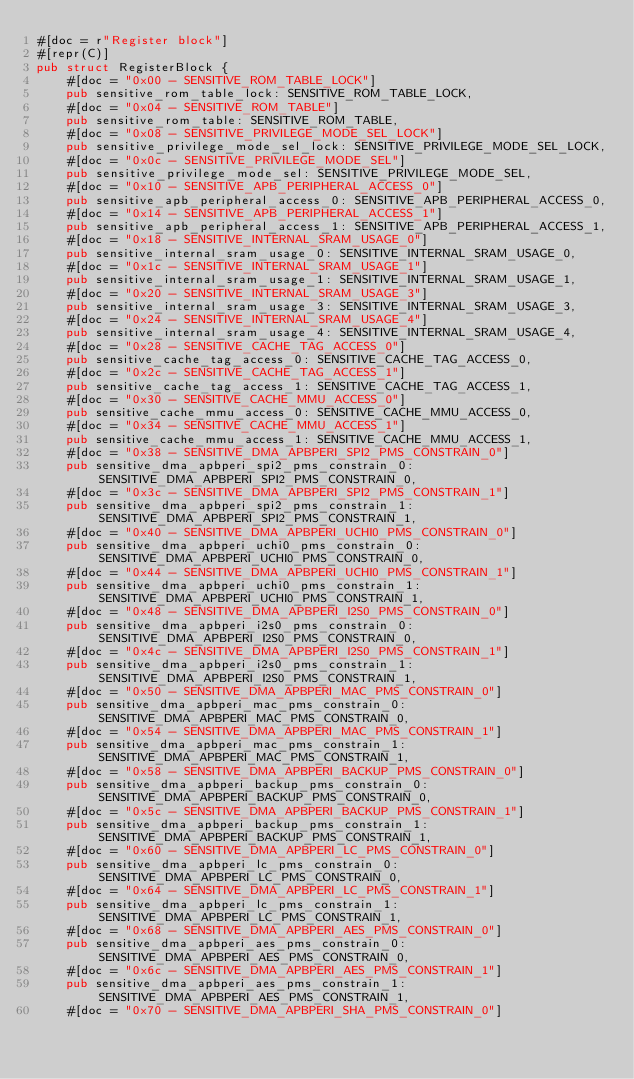<code> <loc_0><loc_0><loc_500><loc_500><_Rust_>#[doc = r"Register block"]
#[repr(C)]
pub struct RegisterBlock {
    #[doc = "0x00 - SENSITIVE_ROM_TABLE_LOCK"]
    pub sensitive_rom_table_lock: SENSITIVE_ROM_TABLE_LOCK,
    #[doc = "0x04 - SENSITIVE_ROM_TABLE"]
    pub sensitive_rom_table: SENSITIVE_ROM_TABLE,
    #[doc = "0x08 - SENSITIVE_PRIVILEGE_MODE_SEL_LOCK"]
    pub sensitive_privilege_mode_sel_lock: SENSITIVE_PRIVILEGE_MODE_SEL_LOCK,
    #[doc = "0x0c - SENSITIVE_PRIVILEGE_MODE_SEL"]
    pub sensitive_privilege_mode_sel: SENSITIVE_PRIVILEGE_MODE_SEL,
    #[doc = "0x10 - SENSITIVE_APB_PERIPHERAL_ACCESS_0"]
    pub sensitive_apb_peripheral_access_0: SENSITIVE_APB_PERIPHERAL_ACCESS_0,
    #[doc = "0x14 - SENSITIVE_APB_PERIPHERAL_ACCESS_1"]
    pub sensitive_apb_peripheral_access_1: SENSITIVE_APB_PERIPHERAL_ACCESS_1,
    #[doc = "0x18 - SENSITIVE_INTERNAL_SRAM_USAGE_0"]
    pub sensitive_internal_sram_usage_0: SENSITIVE_INTERNAL_SRAM_USAGE_0,
    #[doc = "0x1c - SENSITIVE_INTERNAL_SRAM_USAGE_1"]
    pub sensitive_internal_sram_usage_1: SENSITIVE_INTERNAL_SRAM_USAGE_1,
    #[doc = "0x20 - SENSITIVE_INTERNAL_SRAM_USAGE_3"]
    pub sensitive_internal_sram_usage_3: SENSITIVE_INTERNAL_SRAM_USAGE_3,
    #[doc = "0x24 - SENSITIVE_INTERNAL_SRAM_USAGE_4"]
    pub sensitive_internal_sram_usage_4: SENSITIVE_INTERNAL_SRAM_USAGE_4,
    #[doc = "0x28 - SENSITIVE_CACHE_TAG_ACCESS_0"]
    pub sensitive_cache_tag_access_0: SENSITIVE_CACHE_TAG_ACCESS_0,
    #[doc = "0x2c - SENSITIVE_CACHE_TAG_ACCESS_1"]
    pub sensitive_cache_tag_access_1: SENSITIVE_CACHE_TAG_ACCESS_1,
    #[doc = "0x30 - SENSITIVE_CACHE_MMU_ACCESS_0"]
    pub sensitive_cache_mmu_access_0: SENSITIVE_CACHE_MMU_ACCESS_0,
    #[doc = "0x34 - SENSITIVE_CACHE_MMU_ACCESS_1"]
    pub sensitive_cache_mmu_access_1: SENSITIVE_CACHE_MMU_ACCESS_1,
    #[doc = "0x38 - SENSITIVE_DMA_APBPERI_SPI2_PMS_CONSTRAIN_0"]
    pub sensitive_dma_apbperi_spi2_pms_constrain_0: SENSITIVE_DMA_APBPERI_SPI2_PMS_CONSTRAIN_0,
    #[doc = "0x3c - SENSITIVE_DMA_APBPERI_SPI2_PMS_CONSTRAIN_1"]
    pub sensitive_dma_apbperi_spi2_pms_constrain_1: SENSITIVE_DMA_APBPERI_SPI2_PMS_CONSTRAIN_1,
    #[doc = "0x40 - SENSITIVE_DMA_APBPERI_UCHI0_PMS_CONSTRAIN_0"]
    pub sensitive_dma_apbperi_uchi0_pms_constrain_0: SENSITIVE_DMA_APBPERI_UCHI0_PMS_CONSTRAIN_0,
    #[doc = "0x44 - SENSITIVE_DMA_APBPERI_UCHI0_PMS_CONSTRAIN_1"]
    pub sensitive_dma_apbperi_uchi0_pms_constrain_1: SENSITIVE_DMA_APBPERI_UCHI0_PMS_CONSTRAIN_1,
    #[doc = "0x48 - SENSITIVE_DMA_APBPERI_I2S0_PMS_CONSTRAIN_0"]
    pub sensitive_dma_apbperi_i2s0_pms_constrain_0: SENSITIVE_DMA_APBPERI_I2S0_PMS_CONSTRAIN_0,
    #[doc = "0x4c - SENSITIVE_DMA_APBPERI_I2S0_PMS_CONSTRAIN_1"]
    pub sensitive_dma_apbperi_i2s0_pms_constrain_1: SENSITIVE_DMA_APBPERI_I2S0_PMS_CONSTRAIN_1,
    #[doc = "0x50 - SENSITIVE_DMA_APBPERI_MAC_PMS_CONSTRAIN_0"]
    pub sensitive_dma_apbperi_mac_pms_constrain_0: SENSITIVE_DMA_APBPERI_MAC_PMS_CONSTRAIN_0,
    #[doc = "0x54 - SENSITIVE_DMA_APBPERI_MAC_PMS_CONSTRAIN_1"]
    pub sensitive_dma_apbperi_mac_pms_constrain_1: SENSITIVE_DMA_APBPERI_MAC_PMS_CONSTRAIN_1,
    #[doc = "0x58 - SENSITIVE_DMA_APBPERI_BACKUP_PMS_CONSTRAIN_0"]
    pub sensitive_dma_apbperi_backup_pms_constrain_0: SENSITIVE_DMA_APBPERI_BACKUP_PMS_CONSTRAIN_0,
    #[doc = "0x5c - SENSITIVE_DMA_APBPERI_BACKUP_PMS_CONSTRAIN_1"]
    pub sensitive_dma_apbperi_backup_pms_constrain_1: SENSITIVE_DMA_APBPERI_BACKUP_PMS_CONSTRAIN_1,
    #[doc = "0x60 - SENSITIVE_DMA_APBPERI_LC_PMS_CONSTRAIN_0"]
    pub sensitive_dma_apbperi_lc_pms_constrain_0: SENSITIVE_DMA_APBPERI_LC_PMS_CONSTRAIN_0,
    #[doc = "0x64 - SENSITIVE_DMA_APBPERI_LC_PMS_CONSTRAIN_1"]
    pub sensitive_dma_apbperi_lc_pms_constrain_1: SENSITIVE_DMA_APBPERI_LC_PMS_CONSTRAIN_1,
    #[doc = "0x68 - SENSITIVE_DMA_APBPERI_AES_PMS_CONSTRAIN_0"]
    pub sensitive_dma_apbperi_aes_pms_constrain_0: SENSITIVE_DMA_APBPERI_AES_PMS_CONSTRAIN_0,
    #[doc = "0x6c - SENSITIVE_DMA_APBPERI_AES_PMS_CONSTRAIN_1"]
    pub sensitive_dma_apbperi_aes_pms_constrain_1: SENSITIVE_DMA_APBPERI_AES_PMS_CONSTRAIN_1,
    #[doc = "0x70 - SENSITIVE_DMA_APBPERI_SHA_PMS_CONSTRAIN_0"]</code> 